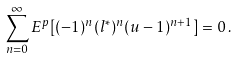Convert formula to latex. <formula><loc_0><loc_0><loc_500><loc_500>\sum _ { n = 0 } ^ { \infty } E ^ { p } [ ( - 1 ) ^ { n } ( l ^ { * } ) ^ { n } ( u - 1 ) ^ { n + 1 } ] = 0 \, .</formula> 